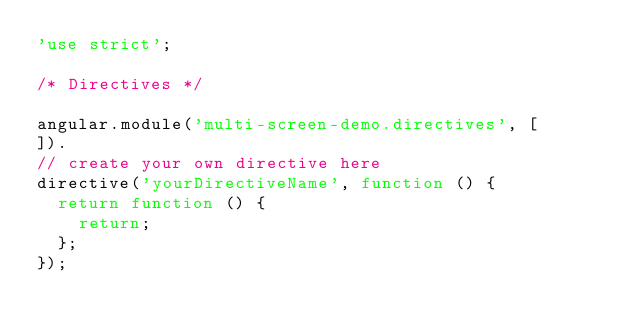Convert code to text. <code><loc_0><loc_0><loc_500><loc_500><_JavaScript_>'use strict';

/* Directives */

angular.module('multi-screen-demo.directives', [
]).
// create your own directive here
directive('yourDirectiveName', function () {
  return function () {
    return;
  };
});</code> 